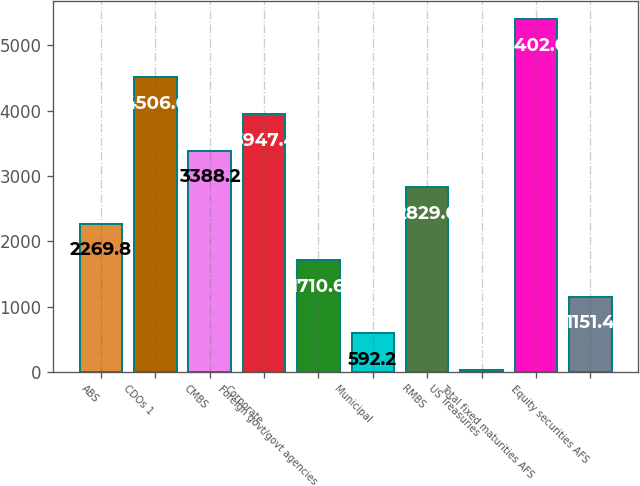Convert chart. <chart><loc_0><loc_0><loc_500><loc_500><bar_chart><fcel>ABS<fcel>CDOs 1<fcel>CMBS<fcel>Corporate<fcel>Foreign govt/govt agencies<fcel>Municipal<fcel>RMBS<fcel>US Treasuries<fcel>Total fixed maturities AFS<fcel>Equity securities AFS<nl><fcel>2269.8<fcel>4506.6<fcel>3388.2<fcel>3947.4<fcel>1710.6<fcel>592.2<fcel>2829<fcel>33<fcel>5402<fcel>1151.4<nl></chart> 